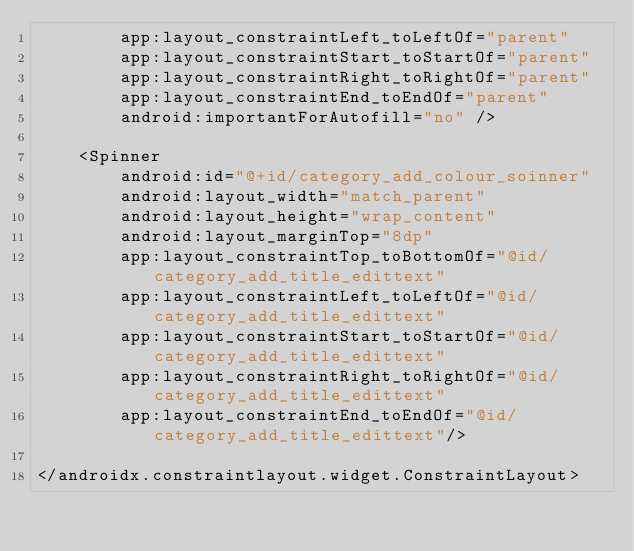Convert code to text. <code><loc_0><loc_0><loc_500><loc_500><_XML_>        app:layout_constraintLeft_toLeftOf="parent"
        app:layout_constraintStart_toStartOf="parent"
        app:layout_constraintRight_toRightOf="parent"
        app:layout_constraintEnd_toEndOf="parent"
        android:importantForAutofill="no" />

    <Spinner
        android:id="@+id/category_add_colour_soinner"
        android:layout_width="match_parent"
        android:layout_height="wrap_content"
        android:layout_marginTop="8dp"
        app:layout_constraintTop_toBottomOf="@id/category_add_title_edittext"
        app:layout_constraintLeft_toLeftOf="@id/category_add_title_edittext"
        app:layout_constraintStart_toStartOf="@id/category_add_title_edittext"
        app:layout_constraintRight_toRightOf="@id/category_add_title_edittext"
        app:layout_constraintEnd_toEndOf="@id/category_add_title_edittext"/>

</androidx.constraintlayout.widget.ConstraintLayout></code> 